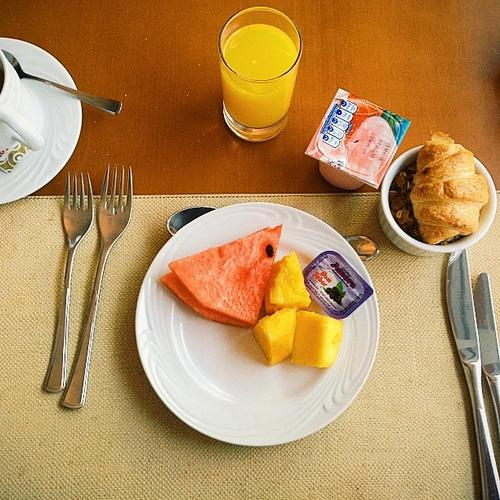Find the beverage options available in the image and describe their containers. There is a full glass of orange juice in a clear round glass and a cup of coffee in a white cup and saucer. In a visual entailment task, explain how the plate and the mat are related to each other in the image. The white plate containing food is sitting on top of a beige place mat, creating a functional and aesthetically pleasing arrangement. What can you find on the white ceramic plate? There are two slices of watermelon, three chunks of pineapple, and a packet of grape jelly on the white ceramic plate. Which objects are part of the place setting in the image? Two forks, two knives, a plate with food, a cup of coffee on a saucer, and a beige placemat are part of the place setting. Choose the product in the image with the most colorful content, and describe it briefly. The container of fruit flavored yogurt with a pink and blue top is the most colorful product in the image. What is the type of pastry present in the image, and where is it located? There is a butter croissant located in a ramekin on the table. Where can you find silverware in the image, and what utensils are visible? Silverware includes two forks to the left of the plate, two knives to the right of the plate, and a small spoon partially hidden under the plate. How would you advertise the image as a slice of morning breakfast? Start your day with a refreshing breakfast, featuring juicy watermelon and pineapple, a delicious croissant and a nutritious yogurt, accompanied by a delightful glass of orange juice and a warm cup of coffee. Give a brief description of the scene with attention to the objects on the plate. The scene includes a white ceramic plate with watermelon slices, pineapple chunks, and grape jelly, as well as utensils, a yogurt container, a croissant, a glass of orange juice, and a cup of coffee on a beige place mat. For the referential expression grounding task, identify the objects mentioned in this sentence: "The glass of orange juice sits near the container of yogurt and a baked pastry." The objects mentioned are a glass of orange juice, a container of yogurt, and a baked pastry (a croissant). 